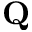<formula> <loc_0><loc_0><loc_500><loc_500>Q</formula> 